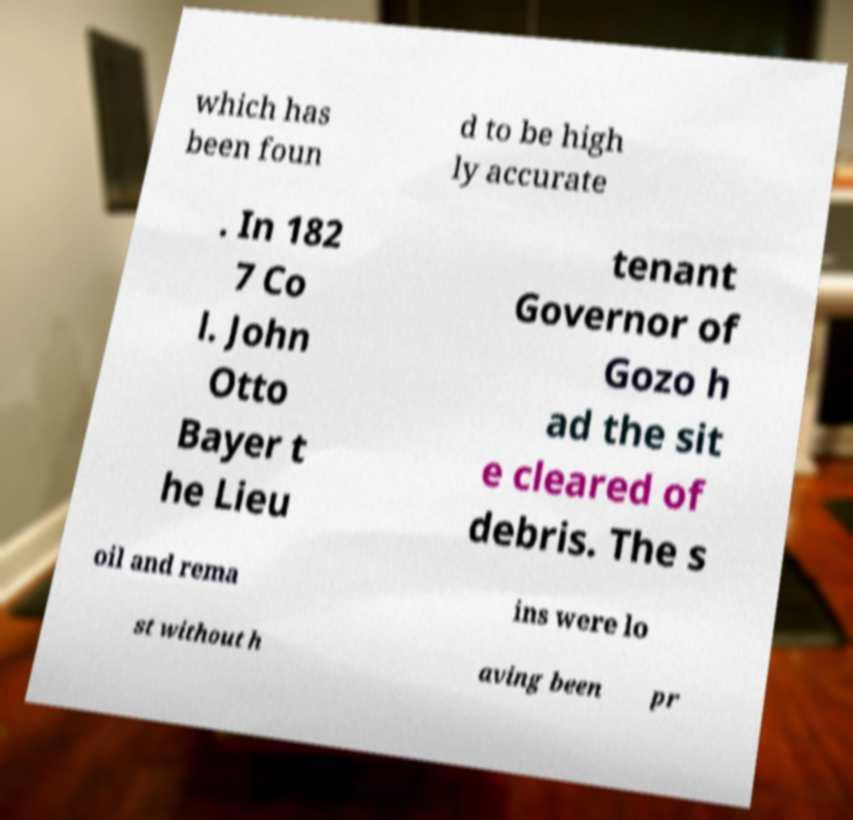For documentation purposes, I need the text within this image transcribed. Could you provide that? which has been foun d to be high ly accurate . In 182 7 Co l. John Otto Bayer t he Lieu tenant Governor of Gozo h ad the sit e cleared of debris. The s oil and rema ins were lo st without h aving been pr 